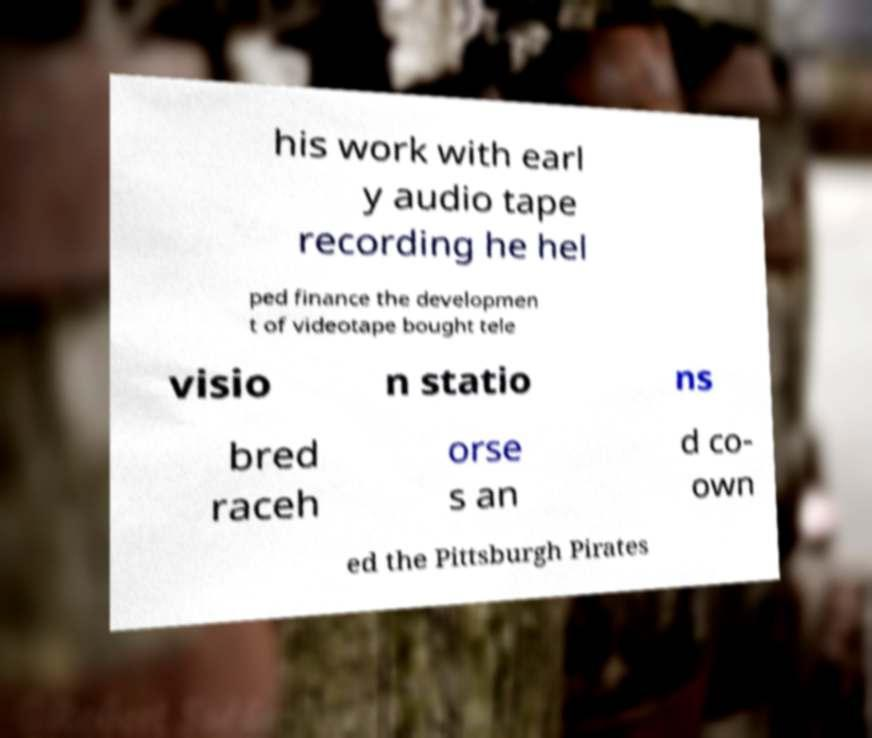Could you extract and type out the text from this image? his work with earl y audio tape recording he hel ped finance the developmen t of videotape bought tele visio n statio ns bred raceh orse s an d co- own ed the Pittsburgh Pirates 